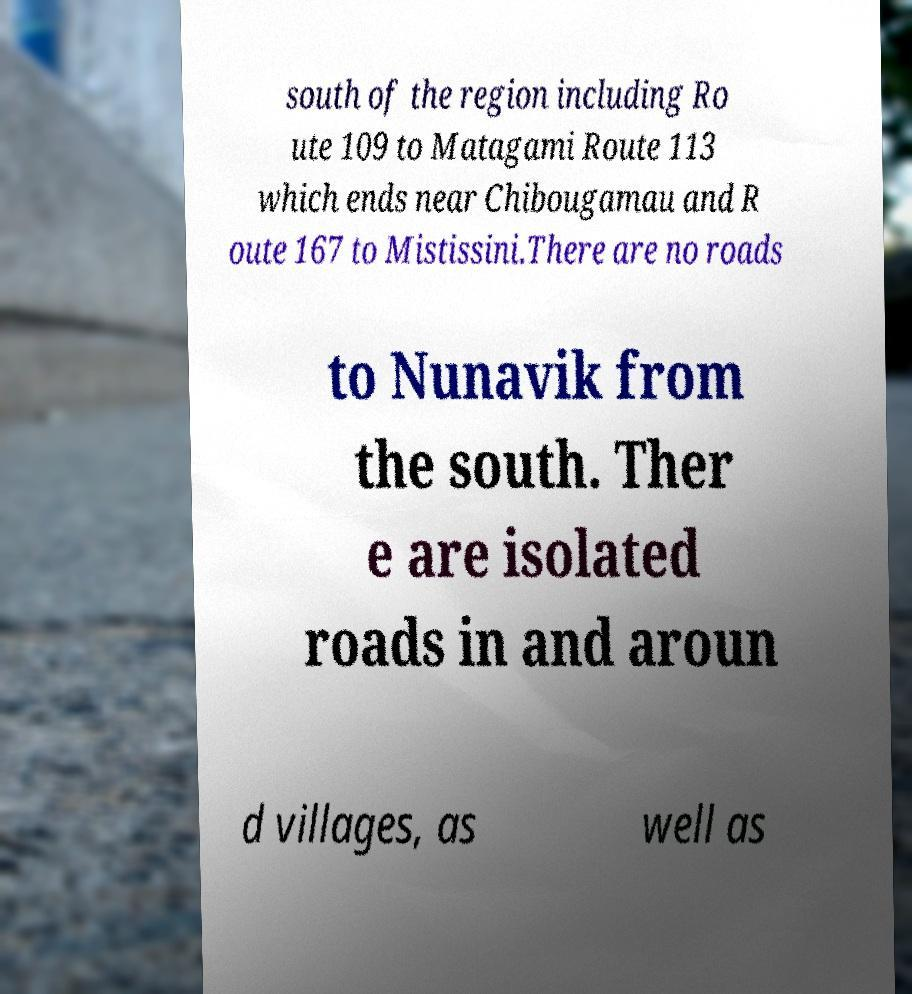Please read and relay the text visible in this image. What does it say? south of the region including Ro ute 109 to Matagami Route 113 which ends near Chibougamau and R oute 167 to Mistissini.There are no roads to Nunavik from the south. Ther e are isolated roads in and aroun d villages, as well as 